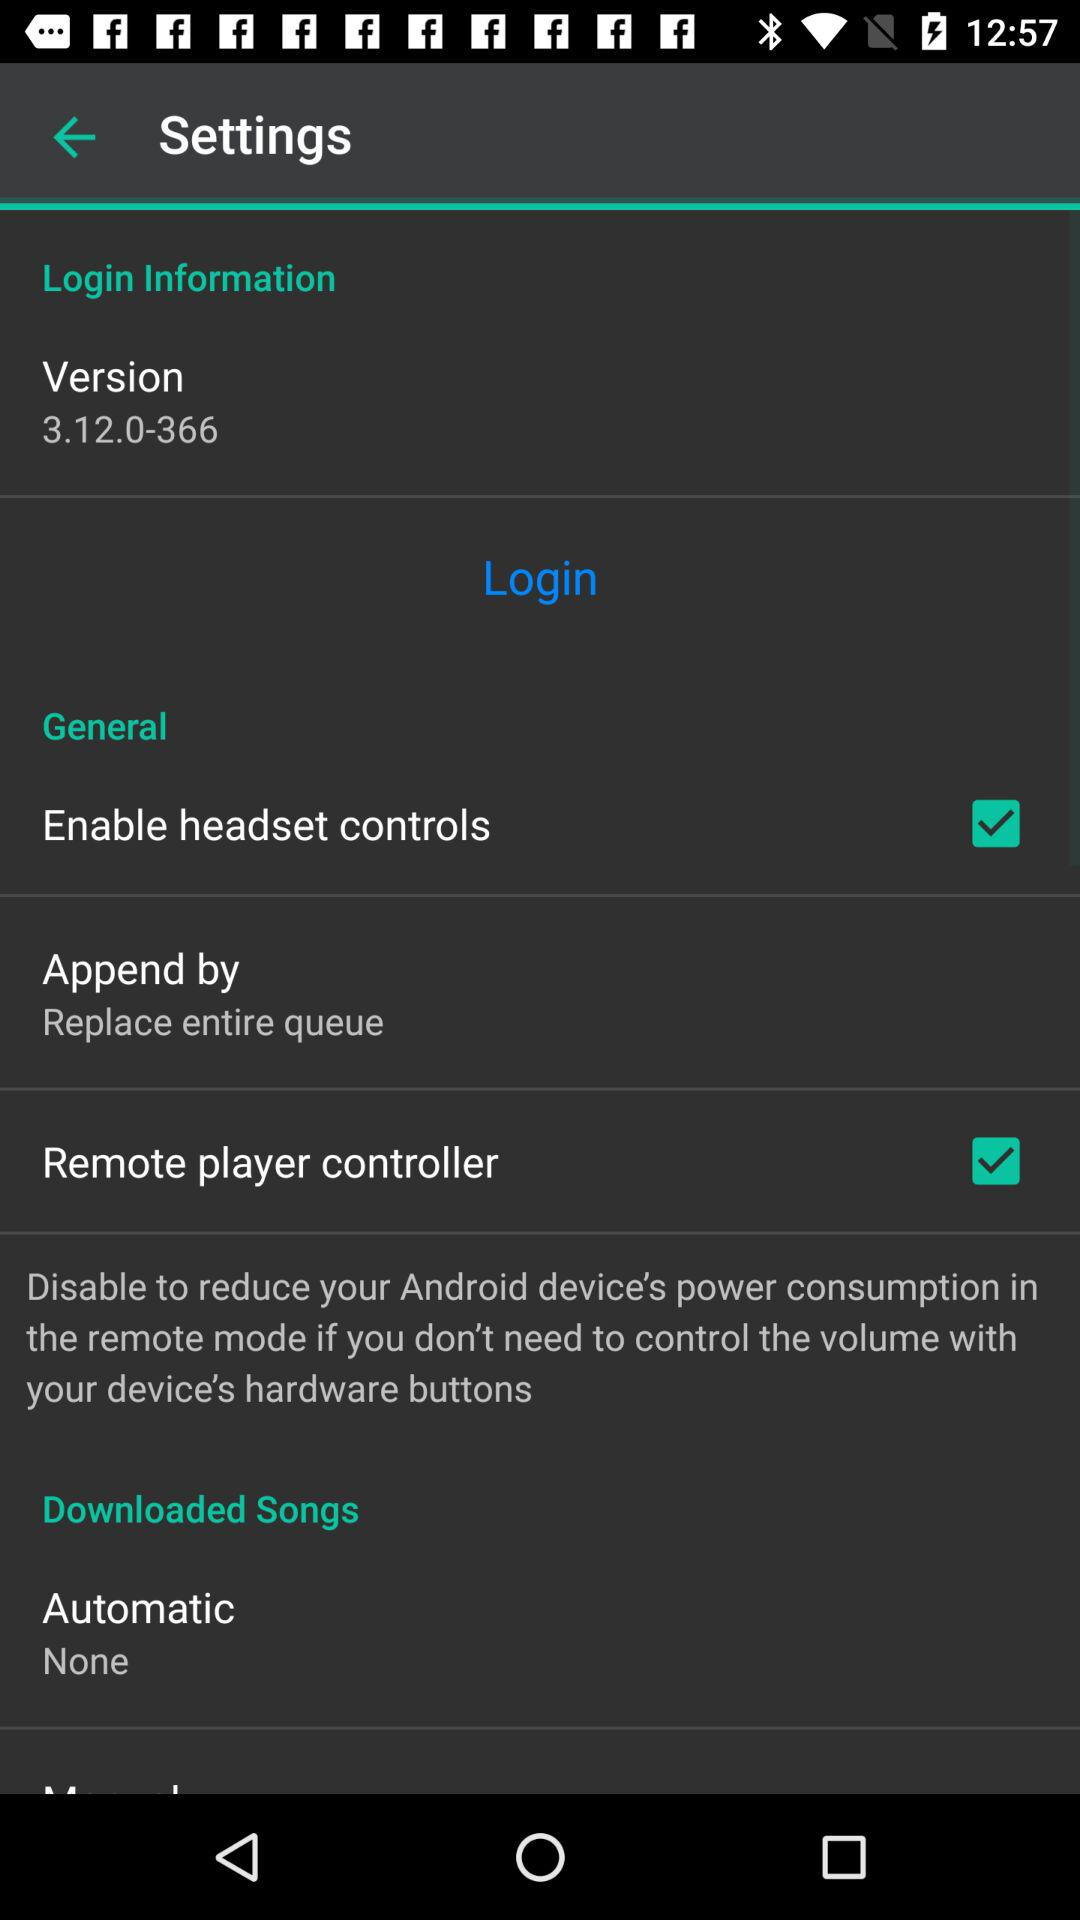For which setting is "None" selected? "None" is selected for the "Automatic" setting. 